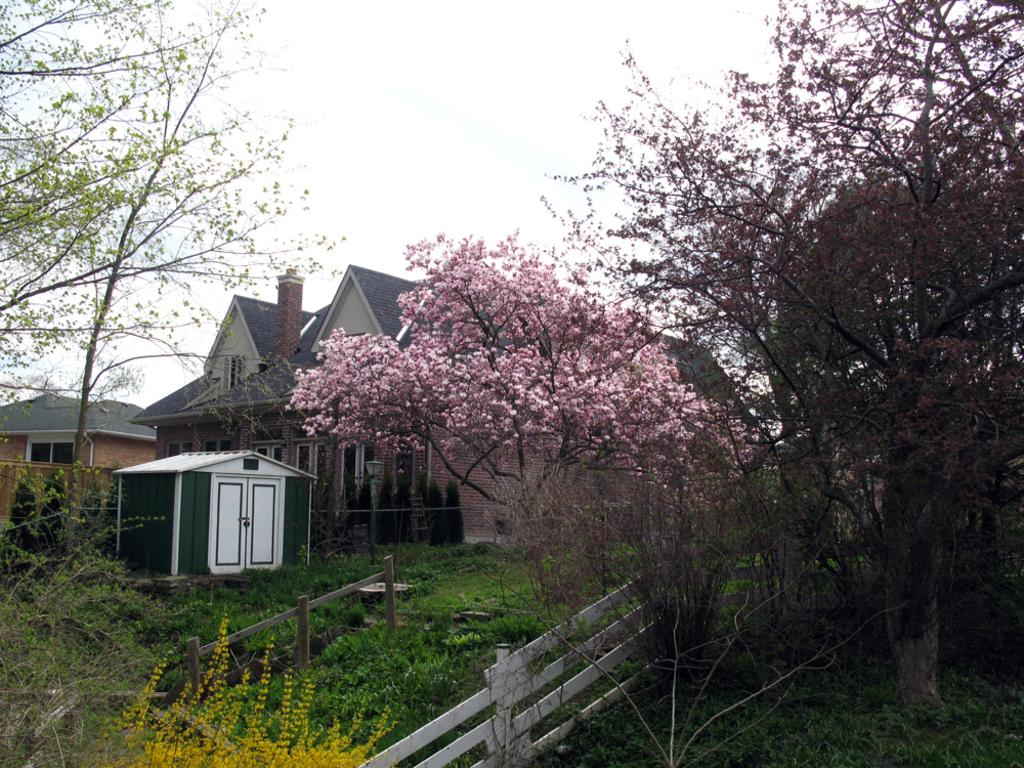What type of structures are located on the left side of the image? There are houses on the left side of the image. What can be seen in the middle of the image? There are trees in the middle of the image. What is at the bottom of the image? There is a wooden fence at the bottom of the image. What is visible at the top of the image? The sky is cloudy and visible at the top of the image. Can you tell me how many patches are on the wooden fence in the image? There is no mention of patches on the wooden fence in the image; it is simply a wooden fence. What type of soda is being served in the image? There is no soda present in the image. 